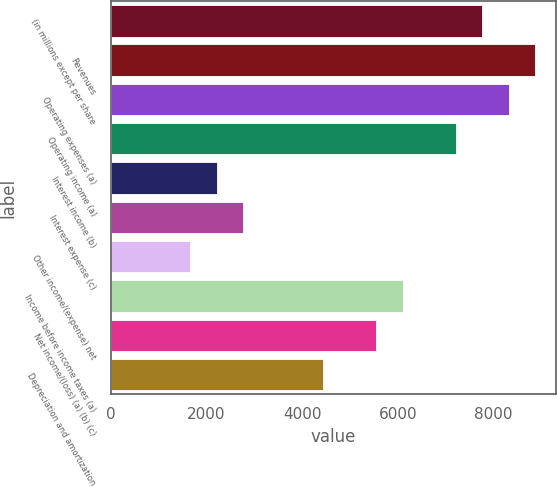Convert chart. <chart><loc_0><loc_0><loc_500><loc_500><bar_chart><fcel>(in millions except per share<fcel>Revenues<fcel>Operating expenses (a)<fcel>Operating income (a)<fcel>Interest income (b)<fcel>Interest expense (c)<fcel>Other income/(expense) net<fcel>Income before income taxes (a)<fcel>Net income/(loss) (a) (b) (c)<fcel>Depreciation and amortization<nl><fcel>7758.6<fcel>8866.9<fcel>8312.75<fcel>7204.45<fcel>2217.1<fcel>2771.25<fcel>1662.95<fcel>6096.15<fcel>5542<fcel>4433.7<nl></chart> 